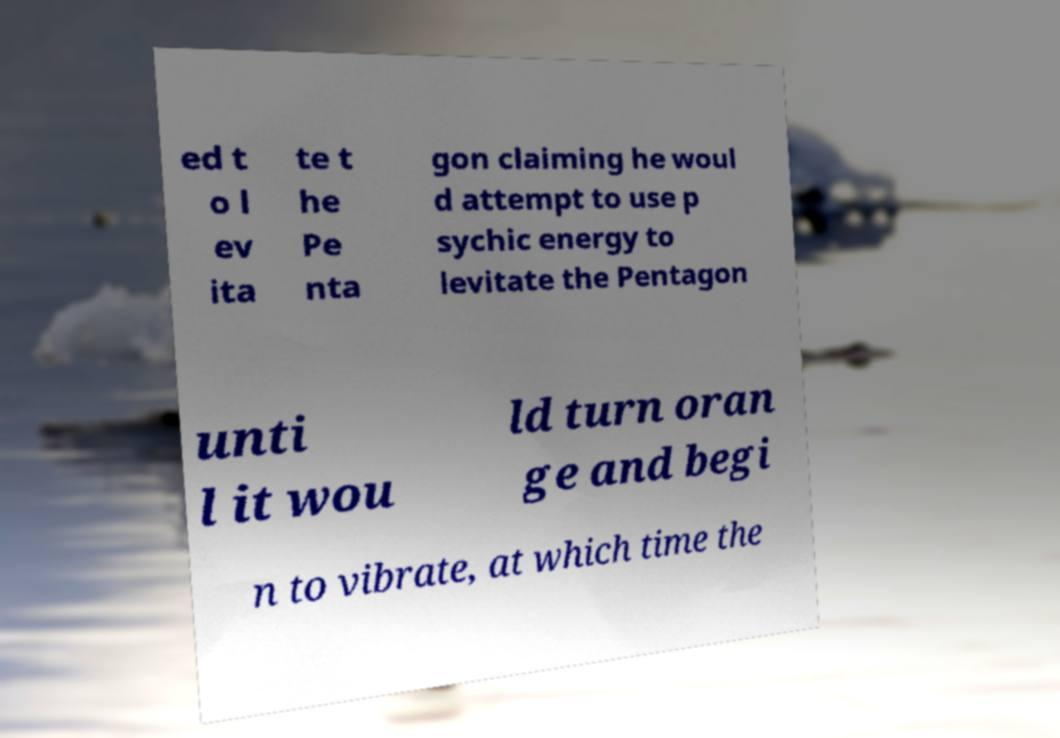Can you accurately transcribe the text from the provided image for me? ed t o l ev ita te t he Pe nta gon claiming he woul d attempt to use p sychic energy to levitate the Pentagon unti l it wou ld turn oran ge and begi n to vibrate, at which time the 